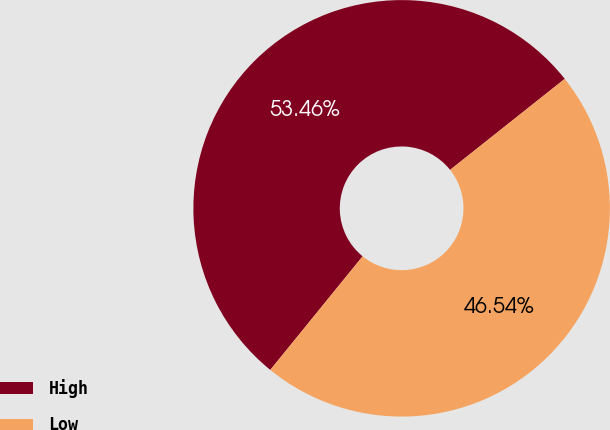<chart> <loc_0><loc_0><loc_500><loc_500><pie_chart><fcel>High<fcel>Low<nl><fcel>53.46%<fcel>46.54%<nl></chart> 